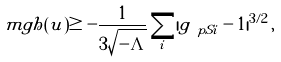<formula> <loc_0><loc_0><loc_500><loc_500>\ m g h ( u ) \geq - \frac { 1 } { 3 \sqrt { - \Lambda } } \sum _ { i } | g _ { \ p S i } - 1 | ^ { 3 / 2 } \, ,</formula> 